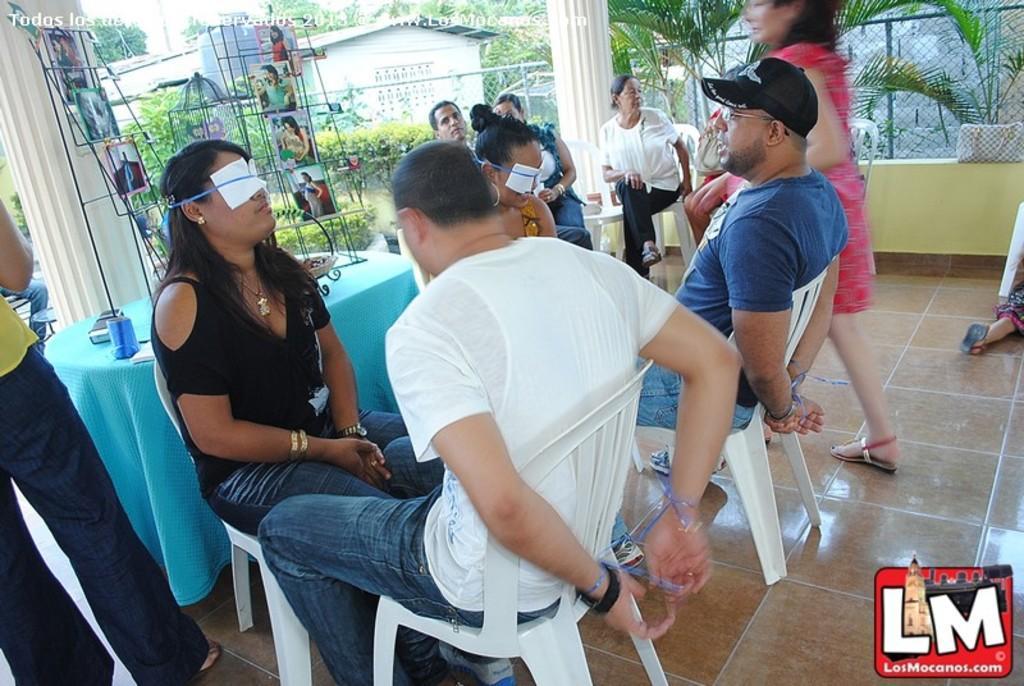In one or two sentences, can you explain what this image depicts? In this image, we can see some plants. There is a table on the left side of the image. There are magazines in a stand which is in the top left of the image. There is a shed at the top of the image. There are some persons in the middle of the image wearing clothes and sitting on chairs. There is a person on the right side of the image walking on the floor. There are person legs in the bottom left of the image. 